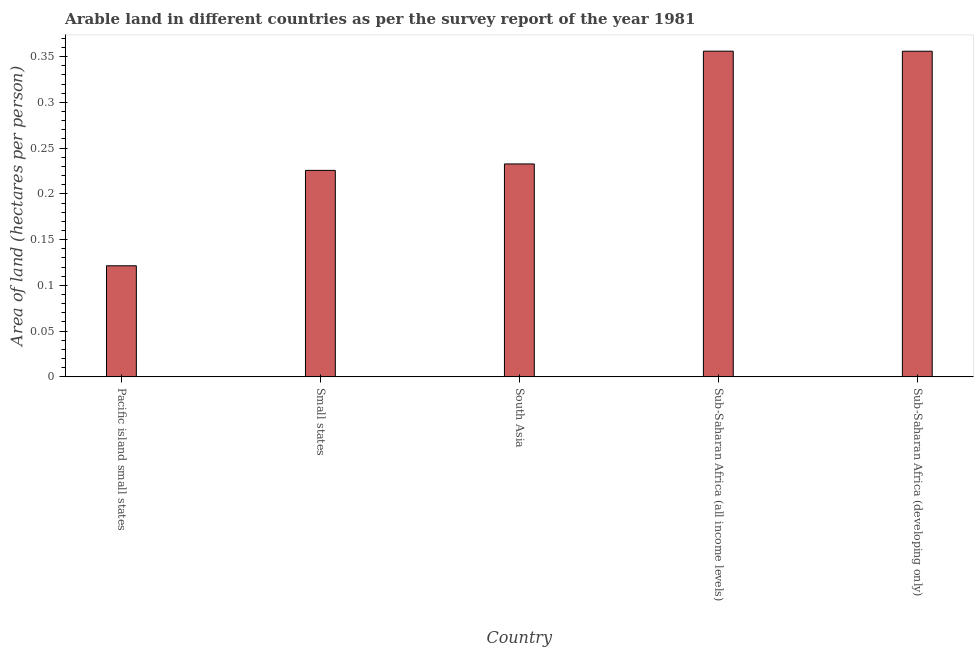Does the graph contain grids?
Ensure brevity in your answer.  No. What is the title of the graph?
Provide a succinct answer. Arable land in different countries as per the survey report of the year 1981. What is the label or title of the Y-axis?
Ensure brevity in your answer.  Area of land (hectares per person). What is the area of arable land in Small states?
Offer a very short reply. 0.23. Across all countries, what is the maximum area of arable land?
Provide a short and direct response. 0.36. Across all countries, what is the minimum area of arable land?
Offer a very short reply. 0.12. In which country was the area of arable land maximum?
Your response must be concise. Sub-Saharan Africa (all income levels). In which country was the area of arable land minimum?
Your answer should be compact. Pacific island small states. What is the sum of the area of arable land?
Your response must be concise. 1.29. What is the difference between the area of arable land in Small states and South Asia?
Provide a succinct answer. -0.01. What is the average area of arable land per country?
Your answer should be compact. 0.26. What is the median area of arable land?
Provide a short and direct response. 0.23. What is the ratio of the area of arable land in South Asia to that in Sub-Saharan Africa (all income levels)?
Ensure brevity in your answer.  0.65. Is the area of arable land in Pacific island small states less than that in South Asia?
Your answer should be compact. Yes. What is the difference between the highest and the second highest area of arable land?
Your answer should be compact. 0. Is the sum of the area of arable land in Small states and Sub-Saharan Africa (developing only) greater than the maximum area of arable land across all countries?
Your answer should be very brief. Yes. What is the difference between the highest and the lowest area of arable land?
Make the answer very short. 0.23. In how many countries, is the area of arable land greater than the average area of arable land taken over all countries?
Ensure brevity in your answer.  2. How many bars are there?
Give a very brief answer. 5. Are all the bars in the graph horizontal?
Make the answer very short. No. What is the difference between two consecutive major ticks on the Y-axis?
Ensure brevity in your answer.  0.05. Are the values on the major ticks of Y-axis written in scientific E-notation?
Your answer should be very brief. No. What is the Area of land (hectares per person) of Pacific island small states?
Provide a succinct answer. 0.12. What is the Area of land (hectares per person) in Small states?
Make the answer very short. 0.23. What is the Area of land (hectares per person) in South Asia?
Offer a very short reply. 0.23. What is the Area of land (hectares per person) in Sub-Saharan Africa (all income levels)?
Make the answer very short. 0.36. What is the Area of land (hectares per person) in Sub-Saharan Africa (developing only)?
Give a very brief answer. 0.36. What is the difference between the Area of land (hectares per person) in Pacific island small states and Small states?
Offer a very short reply. -0.1. What is the difference between the Area of land (hectares per person) in Pacific island small states and South Asia?
Your answer should be compact. -0.11. What is the difference between the Area of land (hectares per person) in Pacific island small states and Sub-Saharan Africa (all income levels)?
Your response must be concise. -0.23. What is the difference between the Area of land (hectares per person) in Pacific island small states and Sub-Saharan Africa (developing only)?
Give a very brief answer. -0.23. What is the difference between the Area of land (hectares per person) in Small states and South Asia?
Provide a succinct answer. -0.01. What is the difference between the Area of land (hectares per person) in Small states and Sub-Saharan Africa (all income levels)?
Provide a short and direct response. -0.13. What is the difference between the Area of land (hectares per person) in Small states and Sub-Saharan Africa (developing only)?
Offer a terse response. -0.13. What is the difference between the Area of land (hectares per person) in South Asia and Sub-Saharan Africa (all income levels)?
Your answer should be compact. -0.12. What is the difference between the Area of land (hectares per person) in South Asia and Sub-Saharan Africa (developing only)?
Give a very brief answer. -0.12. What is the difference between the Area of land (hectares per person) in Sub-Saharan Africa (all income levels) and Sub-Saharan Africa (developing only)?
Keep it short and to the point. 6e-5. What is the ratio of the Area of land (hectares per person) in Pacific island small states to that in Small states?
Provide a succinct answer. 0.54. What is the ratio of the Area of land (hectares per person) in Pacific island small states to that in South Asia?
Provide a short and direct response. 0.52. What is the ratio of the Area of land (hectares per person) in Pacific island small states to that in Sub-Saharan Africa (all income levels)?
Give a very brief answer. 0.34. What is the ratio of the Area of land (hectares per person) in Pacific island small states to that in Sub-Saharan Africa (developing only)?
Ensure brevity in your answer.  0.34. What is the ratio of the Area of land (hectares per person) in Small states to that in South Asia?
Your response must be concise. 0.97. What is the ratio of the Area of land (hectares per person) in Small states to that in Sub-Saharan Africa (all income levels)?
Your response must be concise. 0.63. What is the ratio of the Area of land (hectares per person) in Small states to that in Sub-Saharan Africa (developing only)?
Ensure brevity in your answer.  0.63. What is the ratio of the Area of land (hectares per person) in South Asia to that in Sub-Saharan Africa (all income levels)?
Offer a very short reply. 0.65. What is the ratio of the Area of land (hectares per person) in South Asia to that in Sub-Saharan Africa (developing only)?
Keep it short and to the point. 0.65. What is the ratio of the Area of land (hectares per person) in Sub-Saharan Africa (all income levels) to that in Sub-Saharan Africa (developing only)?
Offer a very short reply. 1. 